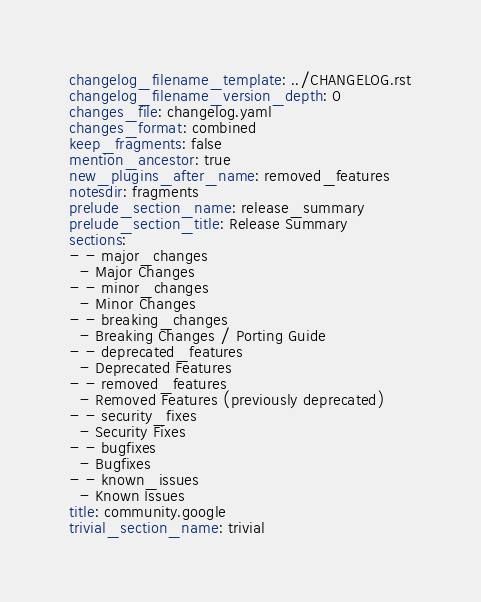Convert code to text. <code><loc_0><loc_0><loc_500><loc_500><_YAML_>changelog_filename_template: ../CHANGELOG.rst
changelog_filename_version_depth: 0
changes_file: changelog.yaml
changes_format: combined
keep_fragments: false
mention_ancestor: true
new_plugins_after_name: removed_features
notesdir: fragments
prelude_section_name: release_summary
prelude_section_title: Release Summary
sections:
- - major_changes
  - Major Changes
- - minor_changes
  - Minor Changes
- - breaking_changes
  - Breaking Changes / Porting Guide
- - deprecated_features
  - Deprecated Features
- - removed_features
  - Removed Features (previously deprecated)
- - security_fixes
  - Security Fixes
- - bugfixes
  - Bugfixes
- - known_issues
  - Known Issues
title: community.google
trivial_section_name: trivial
</code> 